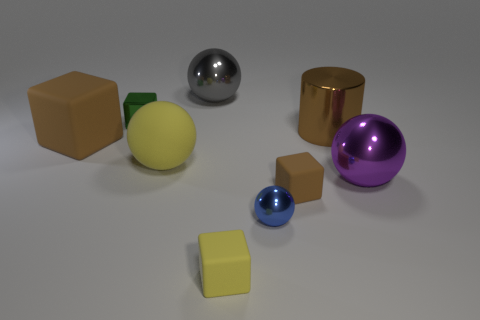What can you infer about the purpose of this scene? This scene appears to be a synthetic setup, possibly created for the purpose of showcasing various geometric shapes and materials. It may be used as a visual reference or in educational contexts to study shapes, lighting, and textures in 3D modeling and rendering. 